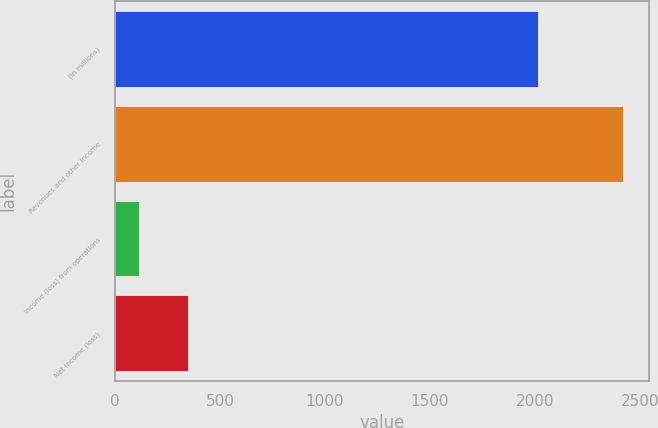Convert chart. <chart><loc_0><loc_0><loc_500><loc_500><bar_chart><fcel>(In millions)<fcel>Revenues and other income<fcel>Income (loss) from operations<fcel>Net income (loss)<nl><fcel>2016<fcel>2421<fcel>116<fcel>346.5<nl></chart> 